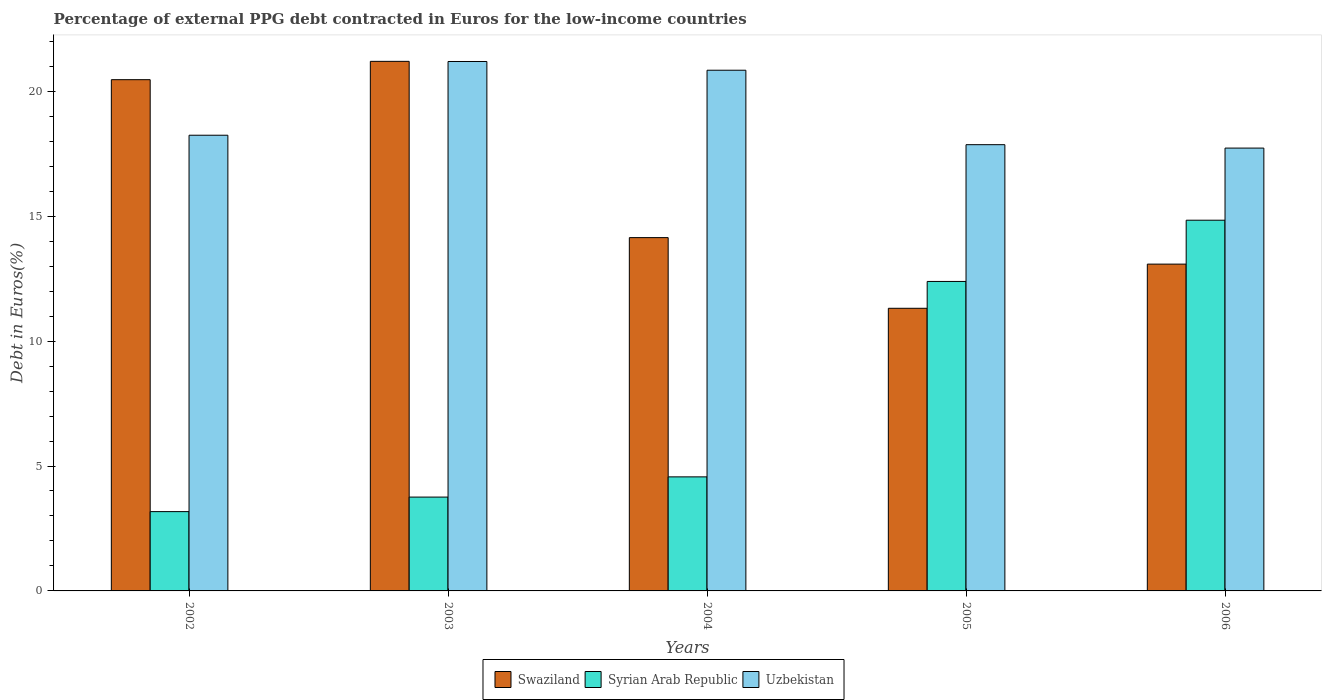How many different coloured bars are there?
Your response must be concise. 3. How many groups of bars are there?
Your response must be concise. 5. Are the number of bars on each tick of the X-axis equal?
Offer a terse response. Yes. What is the label of the 3rd group of bars from the left?
Provide a short and direct response. 2004. What is the percentage of external PPG debt contracted in Euros in Syrian Arab Republic in 2005?
Your answer should be compact. 12.39. Across all years, what is the maximum percentage of external PPG debt contracted in Euros in Syrian Arab Republic?
Provide a succinct answer. 14.84. Across all years, what is the minimum percentage of external PPG debt contracted in Euros in Syrian Arab Republic?
Your answer should be compact. 3.17. In which year was the percentage of external PPG debt contracted in Euros in Uzbekistan maximum?
Provide a succinct answer. 2003. In which year was the percentage of external PPG debt contracted in Euros in Swaziland minimum?
Your answer should be compact. 2005. What is the total percentage of external PPG debt contracted in Euros in Syrian Arab Republic in the graph?
Keep it short and to the point. 38.73. What is the difference between the percentage of external PPG debt contracted in Euros in Uzbekistan in 2004 and that in 2005?
Keep it short and to the point. 2.98. What is the difference between the percentage of external PPG debt contracted in Euros in Swaziland in 2005 and the percentage of external PPG debt contracted in Euros in Syrian Arab Republic in 2006?
Offer a very short reply. -3.53. What is the average percentage of external PPG debt contracted in Euros in Syrian Arab Republic per year?
Ensure brevity in your answer.  7.75. In the year 2002, what is the difference between the percentage of external PPG debt contracted in Euros in Uzbekistan and percentage of external PPG debt contracted in Euros in Swaziland?
Your answer should be compact. -2.22. What is the ratio of the percentage of external PPG debt contracted in Euros in Syrian Arab Republic in 2003 to that in 2004?
Your answer should be very brief. 0.82. Is the difference between the percentage of external PPG debt contracted in Euros in Uzbekistan in 2002 and 2004 greater than the difference between the percentage of external PPG debt contracted in Euros in Swaziland in 2002 and 2004?
Your response must be concise. No. What is the difference between the highest and the second highest percentage of external PPG debt contracted in Euros in Syrian Arab Republic?
Your answer should be compact. 2.45. What is the difference between the highest and the lowest percentage of external PPG debt contracted in Euros in Uzbekistan?
Provide a succinct answer. 3.47. Is the sum of the percentage of external PPG debt contracted in Euros in Swaziland in 2002 and 2003 greater than the maximum percentage of external PPG debt contracted in Euros in Syrian Arab Republic across all years?
Your response must be concise. Yes. What does the 1st bar from the left in 2006 represents?
Give a very brief answer. Swaziland. What does the 3rd bar from the right in 2005 represents?
Give a very brief answer. Swaziland. Does the graph contain grids?
Offer a very short reply. No. How many legend labels are there?
Give a very brief answer. 3. What is the title of the graph?
Your answer should be very brief. Percentage of external PPG debt contracted in Euros for the low-income countries. Does "St. Vincent and the Grenadines" appear as one of the legend labels in the graph?
Offer a very short reply. No. What is the label or title of the X-axis?
Your response must be concise. Years. What is the label or title of the Y-axis?
Keep it short and to the point. Debt in Euros(%). What is the Debt in Euros(%) of Swaziland in 2002?
Give a very brief answer. 20.47. What is the Debt in Euros(%) in Syrian Arab Republic in 2002?
Offer a terse response. 3.17. What is the Debt in Euros(%) of Uzbekistan in 2002?
Keep it short and to the point. 18.24. What is the Debt in Euros(%) in Swaziland in 2003?
Provide a succinct answer. 21.2. What is the Debt in Euros(%) of Syrian Arab Republic in 2003?
Your response must be concise. 3.76. What is the Debt in Euros(%) of Uzbekistan in 2003?
Ensure brevity in your answer.  21.19. What is the Debt in Euros(%) of Swaziland in 2004?
Make the answer very short. 14.14. What is the Debt in Euros(%) of Syrian Arab Republic in 2004?
Offer a very short reply. 4.57. What is the Debt in Euros(%) in Uzbekistan in 2004?
Your response must be concise. 20.84. What is the Debt in Euros(%) of Swaziland in 2005?
Give a very brief answer. 11.31. What is the Debt in Euros(%) of Syrian Arab Republic in 2005?
Ensure brevity in your answer.  12.39. What is the Debt in Euros(%) of Uzbekistan in 2005?
Provide a succinct answer. 17.86. What is the Debt in Euros(%) in Swaziland in 2006?
Offer a very short reply. 13.08. What is the Debt in Euros(%) in Syrian Arab Republic in 2006?
Provide a succinct answer. 14.84. What is the Debt in Euros(%) in Uzbekistan in 2006?
Make the answer very short. 17.73. Across all years, what is the maximum Debt in Euros(%) of Swaziland?
Offer a very short reply. 21.2. Across all years, what is the maximum Debt in Euros(%) of Syrian Arab Republic?
Keep it short and to the point. 14.84. Across all years, what is the maximum Debt in Euros(%) in Uzbekistan?
Your answer should be very brief. 21.19. Across all years, what is the minimum Debt in Euros(%) of Swaziland?
Ensure brevity in your answer.  11.31. Across all years, what is the minimum Debt in Euros(%) in Syrian Arab Republic?
Ensure brevity in your answer.  3.17. Across all years, what is the minimum Debt in Euros(%) of Uzbekistan?
Your response must be concise. 17.73. What is the total Debt in Euros(%) in Swaziland in the graph?
Your answer should be compact. 80.2. What is the total Debt in Euros(%) of Syrian Arab Republic in the graph?
Provide a succinct answer. 38.73. What is the total Debt in Euros(%) in Uzbekistan in the graph?
Provide a short and direct response. 95.87. What is the difference between the Debt in Euros(%) of Swaziland in 2002 and that in 2003?
Your response must be concise. -0.73. What is the difference between the Debt in Euros(%) in Syrian Arab Republic in 2002 and that in 2003?
Offer a very short reply. -0.58. What is the difference between the Debt in Euros(%) in Uzbekistan in 2002 and that in 2003?
Your answer should be compact. -2.95. What is the difference between the Debt in Euros(%) in Swaziland in 2002 and that in 2004?
Offer a very short reply. 6.32. What is the difference between the Debt in Euros(%) in Syrian Arab Republic in 2002 and that in 2004?
Ensure brevity in your answer.  -1.39. What is the difference between the Debt in Euros(%) of Uzbekistan in 2002 and that in 2004?
Your response must be concise. -2.6. What is the difference between the Debt in Euros(%) of Swaziland in 2002 and that in 2005?
Give a very brief answer. 9.15. What is the difference between the Debt in Euros(%) of Syrian Arab Republic in 2002 and that in 2005?
Keep it short and to the point. -9.21. What is the difference between the Debt in Euros(%) in Uzbekistan in 2002 and that in 2005?
Give a very brief answer. 0.38. What is the difference between the Debt in Euros(%) in Swaziland in 2002 and that in 2006?
Give a very brief answer. 7.38. What is the difference between the Debt in Euros(%) of Syrian Arab Republic in 2002 and that in 2006?
Give a very brief answer. -11.66. What is the difference between the Debt in Euros(%) of Uzbekistan in 2002 and that in 2006?
Make the answer very short. 0.52. What is the difference between the Debt in Euros(%) of Swaziland in 2003 and that in 2004?
Your answer should be compact. 7.06. What is the difference between the Debt in Euros(%) in Syrian Arab Republic in 2003 and that in 2004?
Offer a very short reply. -0.81. What is the difference between the Debt in Euros(%) of Uzbekistan in 2003 and that in 2004?
Ensure brevity in your answer.  0.35. What is the difference between the Debt in Euros(%) in Swaziland in 2003 and that in 2005?
Provide a succinct answer. 9.88. What is the difference between the Debt in Euros(%) in Syrian Arab Republic in 2003 and that in 2005?
Ensure brevity in your answer.  -8.63. What is the difference between the Debt in Euros(%) in Uzbekistan in 2003 and that in 2005?
Offer a very short reply. 3.33. What is the difference between the Debt in Euros(%) of Swaziland in 2003 and that in 2006?
Give a very brief answer. 8.12. What is the difference between the Debt in Euros(%) of Syrian Arab Republic in 2003 and that in 2006?
Give a very brief answer. -11.08. What is the difference between the Debt in Euros(%) of Uzbekistan in 2003 and that in 2006?
Offer a very short reply. 3.47. What is the difference between the Debt in Euros(%) of Swaziland in 2004 and that in 2005?
Provide a short and direct response. 2.83. What is the difference between the Debt in Euros(%) of Syrian Arab Republic in 2004 and that in 2005?
Keep it short and to the point. -7.82. What is the difference between the Debt in Euros(%) in Uzbekistan in 2004 and that in 2005?
Offer a very short reply. 2.98. What is the difference between the Debt in Euros(%) in Swaziland in 2004 and that in 2006?
Ensure brevity in your answer.  1.06. What is the difference between the Debt in Euros(%) of Syrian Arab Republic in 2004 and that in 2006?
Provide a succinct answer. -10.27. What is the difference between the Debt in Euros(%) of Uzbekistan in 2004 and that in 2006?
Offer a very short reply. 3.12. What is the difference between the Debt in Euros(%) of Swaziland in 2005 and that in 2006?
Offer a terse response. -1.77. What is the difference between the Debt in Euros(%) of Syrian Arab Republic in 2005 and that in 2006?
Give a very brief answer. -2.45. What is the difference between the Debt in Euros(%) in Uzbekistan in 2005 and that in 2006?
Your answer should be very brief. 0.14. What is the difference between the Debt in Euros(%) of Swaziland in 2002 and the Debt in Euros(%) of Syrian Arab Republic in 2003?
Provide a short and direct response. 16.71. What is the difference between the Debt in Euros(%) in Swaziland in 2002 and the Debt in Euros(%) in Uzbekistan in 2003?
Offer a very short reply. -0.73. What is the difference between the Debt in Euros(%) in Syrian Arab Republic in 2002 and the Debt in Euros(%) in Uzbekistan in 2003?
Offer a terse response. -18.02. What is the difference between the Debt in Euros(%) of Swaziland in 2002 and the Debt in Euros(%) of Syrian Arab Republic in 2004?
Your answer should be compact. 15.9. What is the difference between the Debt in Euros(%) in Swaziland in 2002 and the Debt in Euros(%) in Uzbekistan in 2004?
Your answer should be compact. -0.38. What is the difference between the Debt in Euros(%) of Syrian Arab Republic in 2002 and the Debt in Euros(%) of Uzbekistan in 2004?
Provide a short and direct response. -17.67. What is the difference between the Debt in Euros(%) in Swaziland in 2002 and the Debt in Euros(%) in Syrian Arab Republic in 2005?
Your answer should be compact. 8.08. What is the difference between the Debt in Euros(%) in Swaziland in 2002 and the Debt in Euros(%) in Uzbekistan in 2005?
Make the answer very short. 2.6. What is the difference between the Debt in Euros(%) of Syrian Arab Republic in 2002 and the Debt in Euros(%) of Uzbekistan in 2005?
Your answer should be very brief. -14.69. What is the difference between the Debt in Euros(%) in Swaziland in 2002 and the Debt in Euros(%) in Syrian Arab Republic in 2006?
Offer a very short reply. 5.63. What is the difference between the Debt in Euros(%) of Swaziland in 2002 and the Debt in Euros(%) of Uzbekistan in 2006?
Ensure brevity in your answer.  2.74. What is the difference between the Debt in Euros(%) of Syrian Arab Republic in 2002 and the Debt in Euros(%) of Uzbekistan in 2006?
Offer a very short reply. -14.55. What is the difference between the Debt in Euros(%) of Swaziland in 2003 and the Debt in Euros(%) of Syrian Arab Republic in 2004?
Your response must be concise. 16.63. What is the difference between the Debt in Euros(%) in Swaziland in 2003 and the Debt in Euros(%) in Uzbekistan in 2004?
Provide a succinct answer. 0.35. What is the difference between the Debt in Euros(%) of Syrian Arab Republic in 2003 and the Debt in Euros(%) of Uzbekistan in 2004?
Give a very brief answer. -17.09. What is the difference between the Debt in Euros(%) in Swaziland in 2003 and the Debt in Euros(%) in Syrian Arab Republic in 2005?
Make the answer very short. 8.81. What is the difference between the Debt in Euros(%) in Swaziland in 2003 and the Debt in Euros(%) in Uzbekistan in 2005?
Ensure brevity in your answer.  3.34. What is the difference between the Debt in Euros(%) of Syrian Arab Republic in 2003 and the Debt in Euros(%) of Uzbekistan in 2005?
Give a very brief answer. -14.11. What is the difference between the Debt in Euros(%) of Swaziland in 2003 and the Debt in Euros(%) of Syrian Arab Republic in 2006?
Keep it short and to the point. 6.36. What is the difference between the Debt in Euros(%) of Swaziland in 2003 and the Debt in Euros(%) of Uzbekistan in 2006?
Provide a succinct answer. 3.47. What is the difference between the Debt in Euros(%) of Syrian Arab Republic in 2003 and the Debt in Euros(%) of Uzbekistan in 2006?
Your answer should be compact. -13.97. What is the difference between the Debt in Euros(%) of Swaziland in 2004 and the Debt in Euros(%) of Syrian Arab Republic in 2005?
Give a very brief answer. 1.75. What is the difference between the Debt in Euros(%) of Swaziland in 2004 and the Debt in Euros(%) of Uzbekistan in 2005?
Make the answer very short. -3.72. What is the difference between the Debt in Euros(%) in Syrian Arab Republic in 2004 and the Debt in Euros(%) in Uzbekistan in 2005?
Your answer should be very brief. -13.3. What is the difference between the Debt in Euros(%) of Swaziland in 2004 and the Debt in Euros(%) of Syrian Arab Republic in 2006?
Keep it short and to the point. -0.7. What is the difference between the Debt in Euros(%) of Swaziland in 2004 and the Debt in Euros(%) of Uzbekistan in 2006?
Provide a succinct answer. -3.58. What is the difference between the Debt in Euros(%) in Syrian Arab Republic in 2004 and the Debt in Euros(%) in Uzbekistan in 2006?
Offer a very short reply. -13.16. What is the difference between the Debt in Euros(%) in Swaziland in 2005 and the Debt in Euros(%) in Syrian Arab Republic in 2006?
Your response must be concise. -3.53. What is the difference between the Debt in Euros(%) in Swaziland in 2005 and the Debt in Euros(%) in Uzbekistan in 2006?
Your response must be concise. -6.41. What is the difference between the Debt in Euros(%) of Syrian Arab Republic in 2005 and the Debt in Euros(%) of Uzbekistan in 2006?
Give a very brief answer. -5.34. What is the average Debt in Euros(%) in Swaziland per year?
Keep it short and to the point. 16.04. What is the average Debt in Euros(%) in Syrian Arab Republic per year?
Keep it short and to the point. 7.75. What is the average Debt in Euros(%) of Uzbekistan per year?
Make the answer very short. 19.17. In the year 2002, what is the difference between the Debt in Euros(%) of Swaziland and Debt in Euros(%) of Syrian Arab Republic?
Keep it short and to the point. 17.29. In the year 2002, what is the difference between the Debt in Euros(%) in Swaziland and Debt in Euros(%) in Uzbekistan?
Provide a short and direct response. 2.22. In the year 2002, what is the difference between the Debt in Euros(%) of Syrian Arab Republic and Debt in Euros(%) of Uzbekistan?
Keep it short and to the point. -15.07. In the year 2003, what is the difference between the Debt in Euros(%) in Swaziland and Debt in Euros(%) in Syrian Arab Republic?
Offer a terse response. 17.44. In the year 2003, what is the difference between the Debt in Euros(%) of Swaziland and Debt in Euros(%) of Uzbekistan?
Your response must be concise. 0.01. In the year 2003, what is the difference between the Debt in Euros(%) in Syrian Arab Republic and Debt in Euros(%) in Uzbekistan?
Your response must be concise. -17.44. In the year 2004, what is the difference between the Debt in Euros(%) in Swaziland and Debt in Euros(%) in Syrian Arab Republic?
Keep it short and to the point. 9.58. In the year 2004, what is the difference between the Debt in Euros(%) in Swaziland and Debt in Euros(%) in Uzbekistan?
Provide a succinct answer. -6.7. In the year 2004, what is the difference between the Debt in Euros(%) of Syrian Arab Republic and Debt in Euros(%) of Uzbekistan?
Keep it short and to the point. -16.28. In the year 2005, what is the difference between the Debt in Euros(%) of Swaziland and Debt in Euros(%) of Syrian Arab Republic?
Keep it short and to the point. -1.07. In the year 2005, what is the difference between the Debt in Euros(%) in Swaziland and Debt in Euros(%) in Uzbekistan?
Make the answer very short. -6.55. In the year 2005, what is the difference between the Debt in Euros(%) of Syrian Arab Republic and Debt in Euros(%) of Uzbekistan?
Offer a very short reply. -5.47. In the year 2006, what is the difference between the Debt in Euros(%) in Swaziland and Debt in Euros(%) in Syrian Arab Republic?
Your answer should be very brief. -1.76. In the year 2006, what is the difference between the Debt in Euros(%) of Swaziland and Debt in Euros(%) of Uzbekistan?
Provide a succinct answer. -4.64. In the year 2006, what is the difference between the Debt in Euros(%) in Syrian Arab Republic and Debt in Euros(%) in Uzbekistan?
Offer a terse response. -2.89. What is the ratio of the Debt in Euros(%) of Swaziland in 2002 to that in 2003?
Ensure brevity in your answer.  0.97. What is the ratio of the Debt in Euros(%) in Syrian Arab Republic in 2002 to that in 2003?
Make the answer very short. 0.85. What is the ratio of the Debt in Euros(%) of Uzbekistan in 2002 to that in 2003?
Your answer should be compact. 0.86. What is the ratio of the Debt in Euros(%) in Swaziland in 2002 to that in 2004?
Your answer should be compact. 1.45. What is the ratio of the Debt in Euros(%) of Syrian Arab Republic in 2002 to that in 2004?
Give a very brief answer. 0.7. What is the ratio of the Debt in Euros(%) of Uzbekistan in 2002 to that in 2004?
Offer a terse response. 0.88. What is the ratio of the Debt in Euros(%) of Swaziland in 2002 to that in 2005?
Keep it short and to the point. 1.81. What is the ratio of the Debt in Euros(%) in Syrian Arab Republic in 2002 to that in 2005?
Offer a terse response. 0.26. What is the ratio of the Debt in Euros(%) in Uzbekistan in 2002 to that in 2005?
Give a very brief answer. 1.02. What is the ratio of the Debt in Euros(%) in Swaziland in 2002 to that in 2006?
Ensure brevity in your answer.  1.56. What is the ratio of the Debt in Euros(%) in Syrian Arab Republic in 2002 to that in 2006?
Offer a terse response. 0.21. What is the ratio of the Debt in Euros(%) in Uzbekistan in 2002 to that in 2006?
Offer a very short reply. 1.03. What is the ratio of the Debt in Euros(%) in Swaziland in 2003 to that in 2004?
Your answer should be very brief. 1.5. What is the ratio of the Debt in Euros(%) in Syrian Arab Republic in 2003 to that in 2004?
Keep it short and to the point. 0.82. What is the ratio of the Debt in Euros(%) of Uzbekistan in 2003 to that in 2004?
Ensure brevity in your answer.  1.02. What is the ratio of the Debt in Euros(%) in Swaziland in 2003 to that in 2005?
Your answer should be very brief. 1.87. What is the ratio of the Debt in Euros(%) in Syrian Arab Republic in 2003 to that in 2005?
Make the answer very short. 0.3. What is the ratio of the Debt in Euros(%) in Uzbekistan in 2003 to that in 2005?
Ensure brevity in your answer.  1.19. What is the ratio of the Debt in Euros(%) in Swaziland in 2003 to that in 2006?
Make the answer very short. 1.62. What is the ratio of the Debt in Euros(%) of Syrian Arab Republic in 2003 to that in 2006?
Your answer should be compact. 0.25. What is the ratio of the Debt in Euros(%) in Uzbekistan in 2003 to that in 2006?
Your answer should be very brief. 1.2. What is the ratio of the Debt in Euros(%) in Swaziland in 2004 to that in 2005?
Give a very brief answer. 1.25. What is the ratio of the Debt in Euros(%) of Syrian Arab Republic in 2004 to that in 2005?
Provide a short and direct response. 0.37. What is the ratio of the Debt in Euros(%) of Uzbekistan in 2004 to that in 2005?
Give a very brief answer. 1.17. What is the ratio of the Debt in Euros(%) of Swaziland in 2004 to that in 2006?
Offer a very short reply. 1.08. What is the ratio of the Debt in Euros(%) of Syrian Arab Republic in 2004 to that in 2006?
Your response must be concise. 0.31. What is the ratio of the Debt in Euros(%) of Uzbekistan in 2004 to that in 2006?
Ensure brevity in your answer.  1.18. What is the ratio of the Debt in Euros(%) of Swaziland in 2005 to that in 2006?
Provide a short and direct response. 0.86. What is the ratio of the Debt in Euros(%) in Syrian Arab Republic in 2005 to that in 2006?
Provide a short and direct response. 0.83. What is the ratio of the Debt in Euros(%) of Uzbekistan in 2005 to that in 2006?
Give a very brief answer. 1.01. What is the difference between the highest and the second highest Debt in Euros(%) of Swaziland?
Provide a short and direct response. 0.73. What is the difference between the highest and the second highest Debt in Euros(%) in Syrian Arab Republic?
Ensure brevity in your answer.  2.45. What is the difference between the highest and the second highest Debt in Euros(%) of Uzbekistan?
Provide a short and direct response. 0.35. What is the difference between the highest and the lowest Debt in Euros(%) in Swaziland?
Give a very brief answer. 9.88. What is the difference between the highest and the lowest Debt in Euros(%) in Syrian Arab Republic?
Offer a terse response. 11.66. What is the difference between the highest and the lowest Debt in Euros(%) in Uzbekistan?
Your answer should be compact. 3.47. 